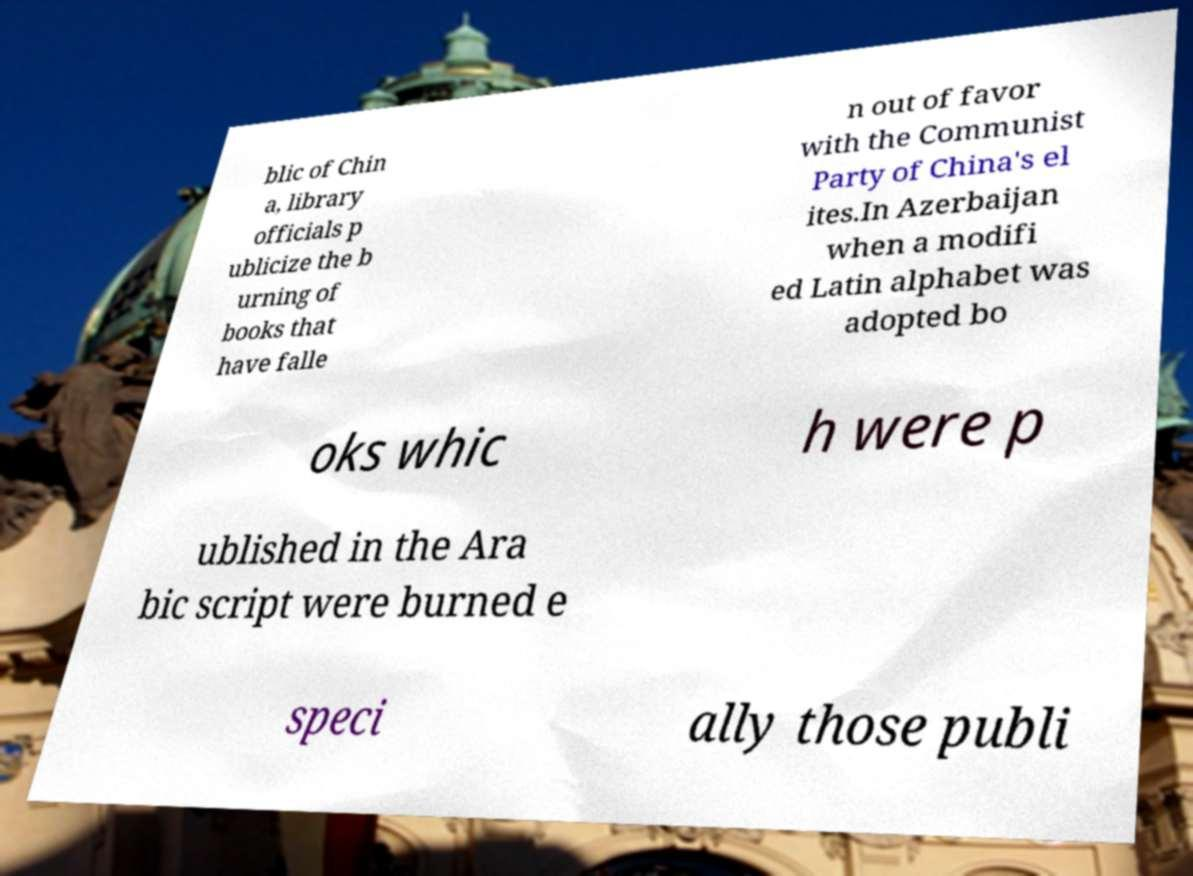Can you read and provide the text displayed in the image?This photo seems to have some interesting text. Can you extract and type it out for me? blic of Chin a, library officials p ublicize the b urning of books that have falle n out of favor with the Communist Party of China's el ites.In Azerbaijan when a modifi ed Latin alphabet was adopted bo oks whic h were p ublished in the Ara bic script were burned e speci ally those publi 